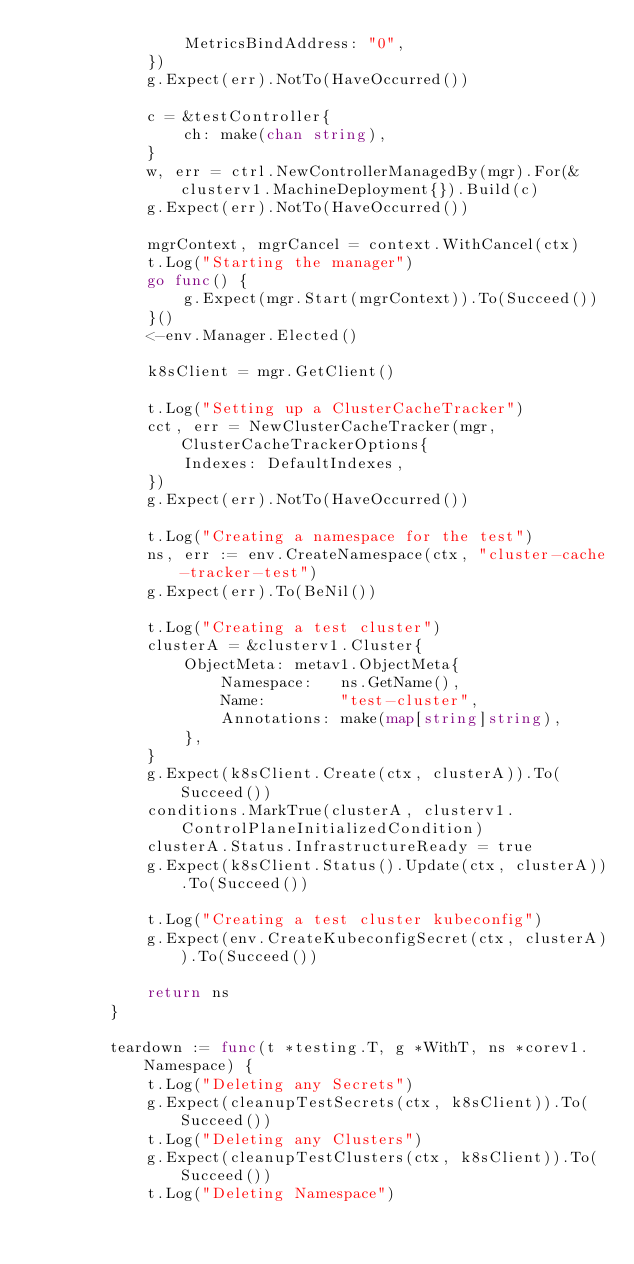Convert code to text. <code><loc_0><loc_0><loc_500><loc_500><_Go_>				MetricsBindAddress: "0",
			})
			g.Expect(err).NotTo(HaveOccurred())

			c = &testController{
				ch: make(chan string),
			}
			w, err = ctrl.NewControllerManagedBy(mgr).For(&clusterv1.MachineDeployment{}).Build(c)
			g.Expect(err).NotTo(HaveOccurred())

			mgrContext, mgrCancel = context.WithCancel(ctx)
			t.Log("Starting the manager")
			go func() {
				g.Expect(mgr.Start(mgrContext)).To(Succeed())
			}()
			<-env.Manager.Elected()

			k8sClient = mgr.GetClient()

			t.Log("Setting up a ClusterCacheTracker")
			cct, err = NewClusterCacheTracker(mgr, ClusterCacheTrackerOptions{
				Indexes: DefaultIndexes,
			})
			g.Expect(err).NotTo(HaveOccurred())

			t.Log("Creating a namespace for the test")
			ns, err := env.CreateNamespace(ctx, "cluster-cache-tracker-test")
			g.Expect(err).To(BeNil())

			t.Log("Creating a test cluster")
			clusterA = &clusterv1.Cluster{
				ObjectMeta: metav1.ObjectMeta{
					Namespace:   ns.GetName(),
					Name:        "test-cluster",
					Annotations: make(map[string]string),
				},
			}
			g.Expect(k8sClient.Create(ctx, clusterA)).To(Succeed())
			conditions.MarkTrue(clusterA, clusterv1.ControlPlaneInitializedCondition)
			clusterA.Status.InfrastructureReady = true
			g.Expect(k8sClient.Status().Update(ctx, clusterA)).To(Succeed())

			t.Log("Creating a test cluster kubeconfig")
			g.Expect(env.CreateKubeconfigSecret(ctx, clusterA)).To(Succeed())

			return ns
		}

		teardown := func(t *testing.T, g *WithT, ns *corev1.Namespace) {
			t.Log("Deleting any Secrets")
			g.Expect(cleanupTestSecrets(ctx, k8sClient)).To(Succeed())
			t.Log("Deleting any Clusters")
			g.Expect(cleanupTestClusters(ctx, k8sClient)).To(Succeed())
			t.Log("Deleting Namespace")</code> 